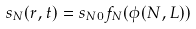<formula> <loc_0><loc_0><loc_500><loc_500>s _ { N } ( r , t ) = s _ { N 0 } f _ { N } ( \phi ( N , L ) )</formula> 